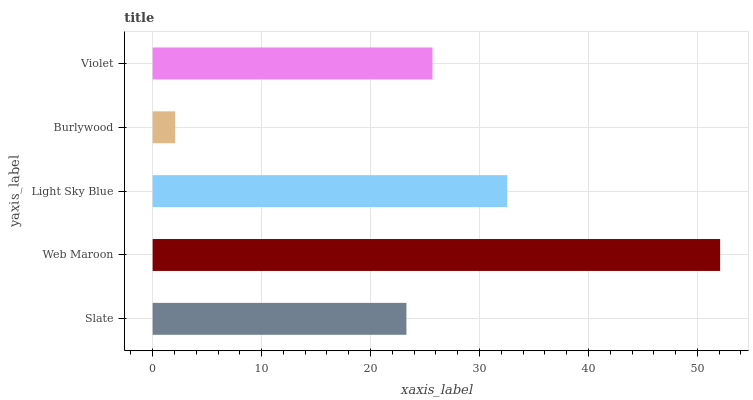Is Burlywood the minimum?
Answer yes or no. Yes. Is Web Maroon the maximum?
Answer yes or no. Yes. Is Light Sky Blue the minimum?
Answer yes or no. No. Is Light Sky Blue the maximum?
Answer yes or no. No. Is Web Maroon greater than Light Sky Blue?
Answer yes or no. Yes. Is Light Sky Blue less than Web Maroon?
Answer yes or no. Yes. Is Light Sky Blue greater than Web Maroon?
Answer yes or no. No. Is Web Maroon less than Light Sky Blue?
Answer yes or no. No. Is Violet the high median?
Answer yes or no. Yes. Is Violet the low median?
Answer yes or no. Yes. Is Light Sky Blue the high median?
Answer yes or no. No. Is Burlywood the low median?
Answer yes or no. No. 